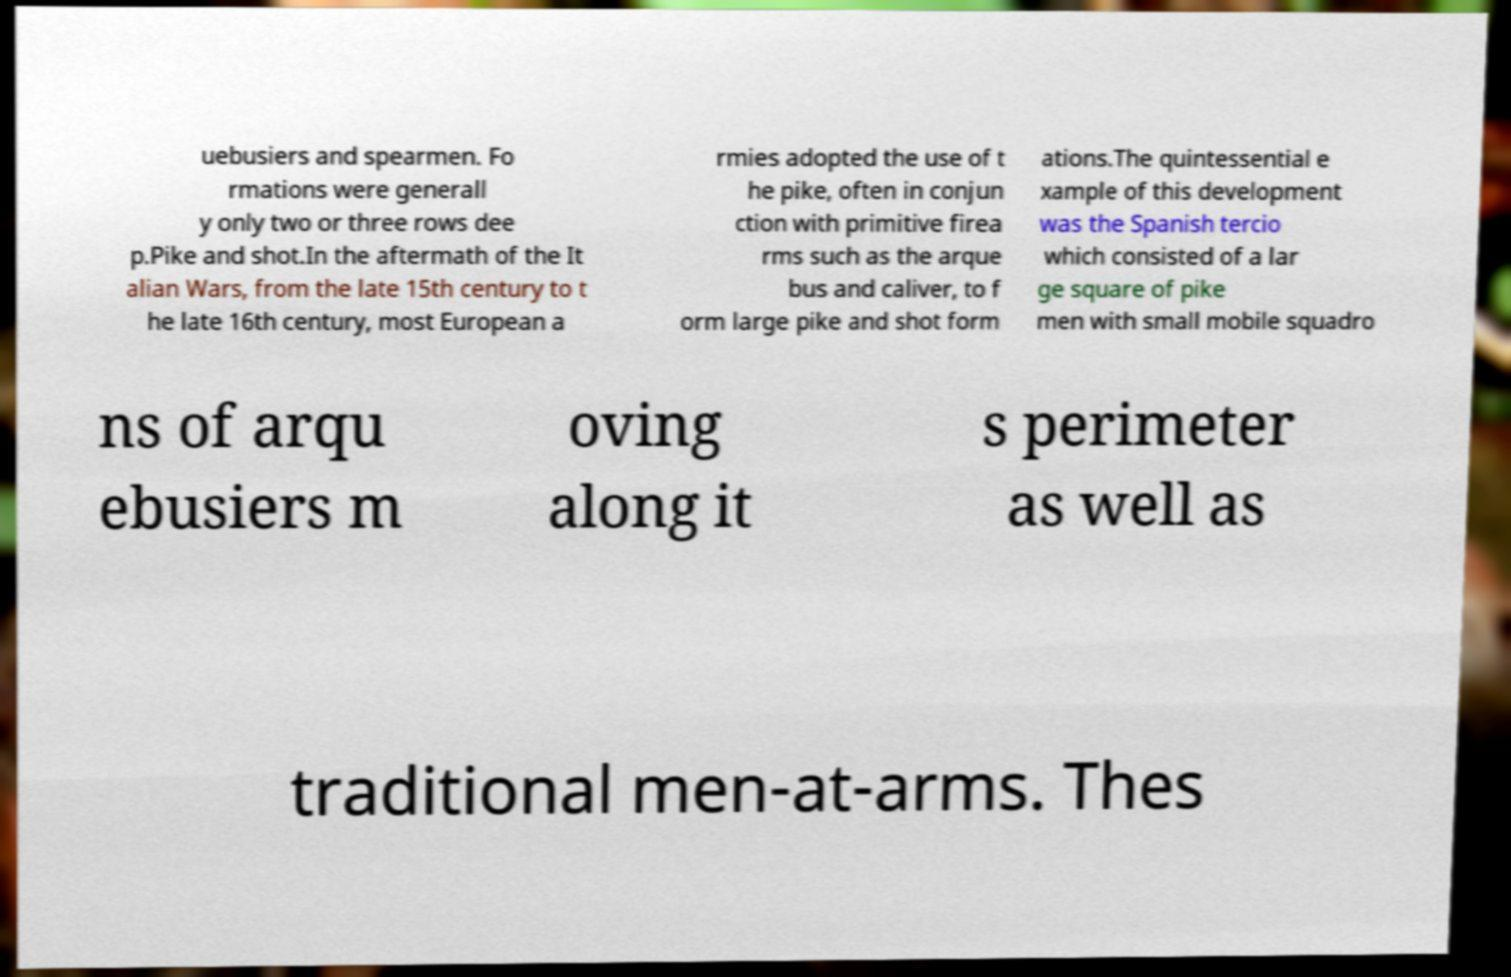Could you extract and type out the text from this image? uebusiers and spearmen. Fo rmations were generall y only two or three rows dee p.Pike and shot.In the aftermath of the It alian Wars, from the late 15th century to t he late 16th century, most European a rmies adopted the use of t he pike, often in conjun ction with primitive firea rms such as the arque bus and caliver, to f orm large pike and shot form ations.The quintessential e xample of this development was the Spanish tercio which consisted of a lar ge square of pike men with small mobile squadro ns of arqu ebusiers m oving along it s perimeter as well as traditional men-at-arms. Thes 